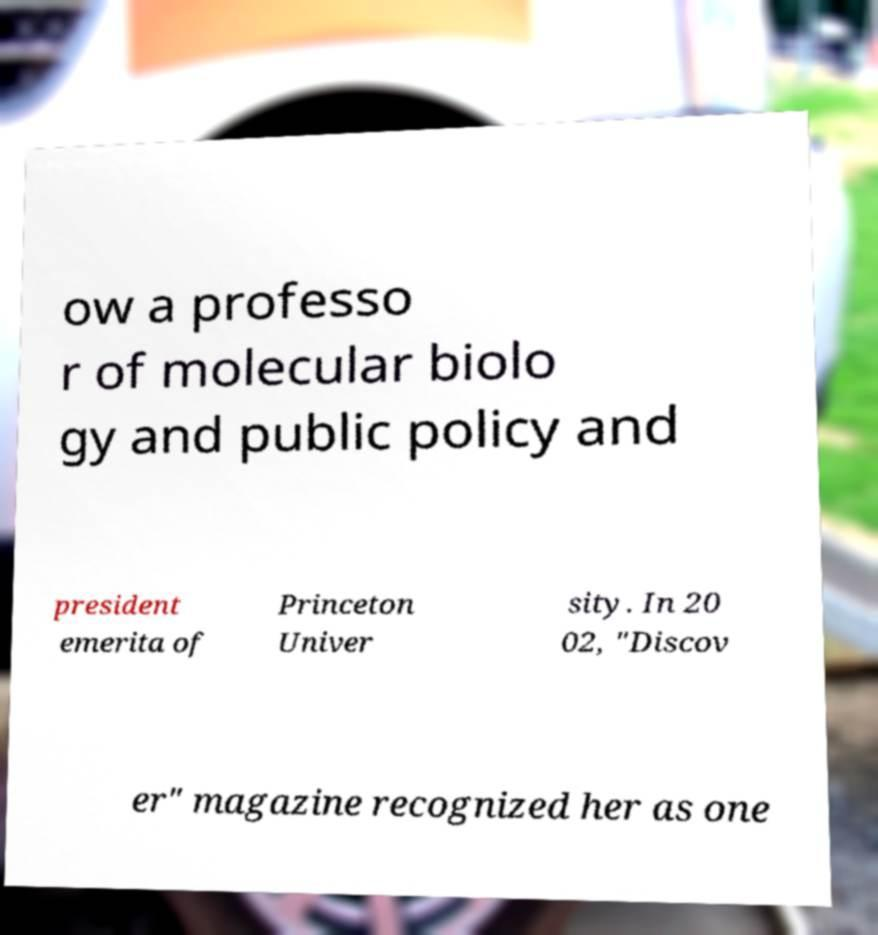For documentation purposes, I need the text within this image transcribed. Could you provide that? ow a professo r of molecular biolo gy and public policy and president emerita of Princeton Univer sity. In 20 02, "Discov er" magazine recognized her as one 